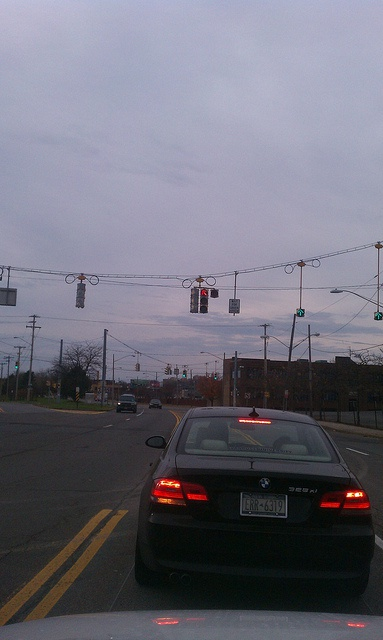Describe the objects in this image and their specific colors. I can see car in lavender, black, gray, and purple tones, car in lavender, gray, brown, black, and salmon tones, traffic light in lavender, black, gray, and darkgray tones, car in lavender, black, gray, and darkblue tones, and traffic light in lavender, gray, and black tones in this image. 